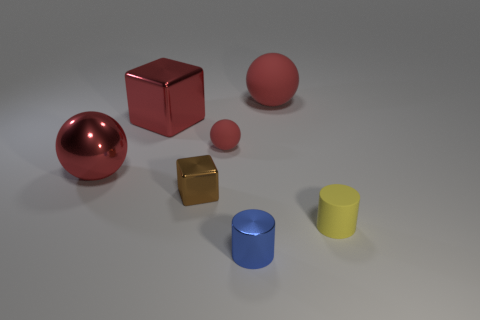What is the size of the block that is the same color as the big matte sphere?
Offer a very short reply. Large. What is the color of the metallic thing that is the same size as the red shiny cube?
Ensure brevity in your answer.  Red. What number of other objects are there of the same shape as the blue shiny thing?
Your answer should be compact. 1. Is there a tiny purple ball made of the same material as the tiny cube?
Provide a short and direct response. No. Is the big thing in front of the tiny red ball made of the same material as the blue object in front of the big matte object?
Your answer should be very brief. Yes. How many large brown matte cylinders are there?
Your answer should be very brief. 0. What is the shape of the small matte object behind the brown shiny object?
Give a very brief answer. Sphere. How many other objects are the same size as the blue metallic object?
Offer a very short reply. 3. There is a small matte object that is left of the tiny blue thing; does it have the same shape as the big thing right of the tiny brown object?
Your answer should be compact. Yes. How many things are left of the small red matte object?
Your answer should be compact. 3. 